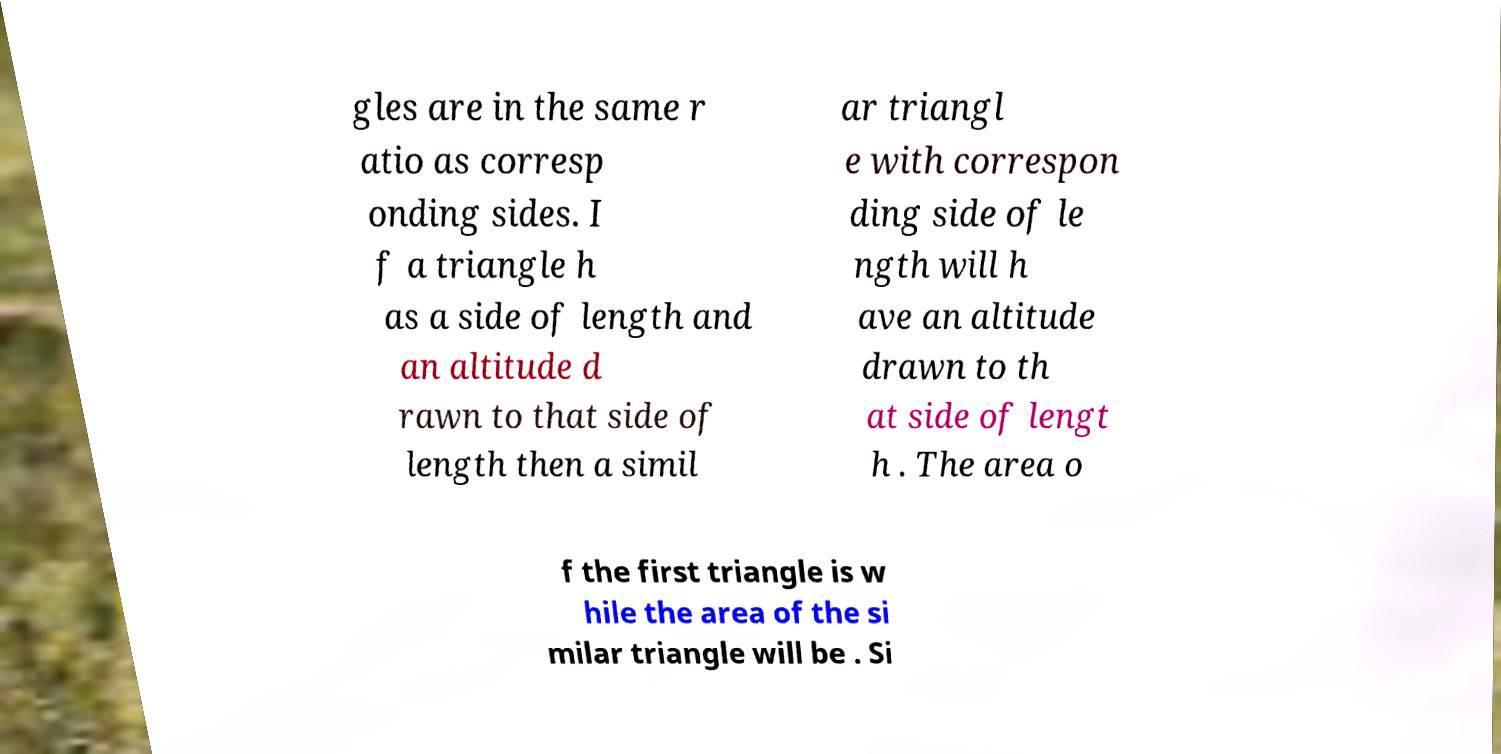Could you extract and type out the text from this image? gles are in the same r atio as corresp onding sides. I f a triangle h as a side of length and an altitude d rawn to that side of length then a simil ar triangl e with correspon ding side of le ngth will h ave an altitude drawn to th at side of lengt h . The area o f the first triangle is w hile the area of the si milar triangle will be . Si 